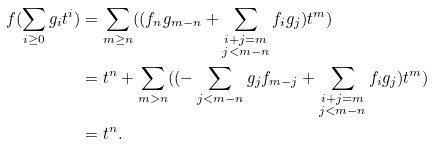Convert formula to latex. <formula><loc_0><loc_0><loc_500><loc_500>f ( \sum _ { i \geq 0 } g _ { i } t ^ { i } ) & = \sum _ { m \geq n } ( ( f _ { n } g _ { m - n } + \sum _ { \substack { i + j = m \\ j < m - n } } f _ { i } g _ { j } ) t ^ { m } ) \\ & = t ^ { n } + \sum _ { m > n } ( ( - \sum _ { j < m - n } g _ { j } f _ { m - j } + \sum _ { \substack { i + j = m \\ j < m - n } } f _ { i } g _ { j } ) t ^ { m } ) \\ & = t ^ { n } .</formula> 